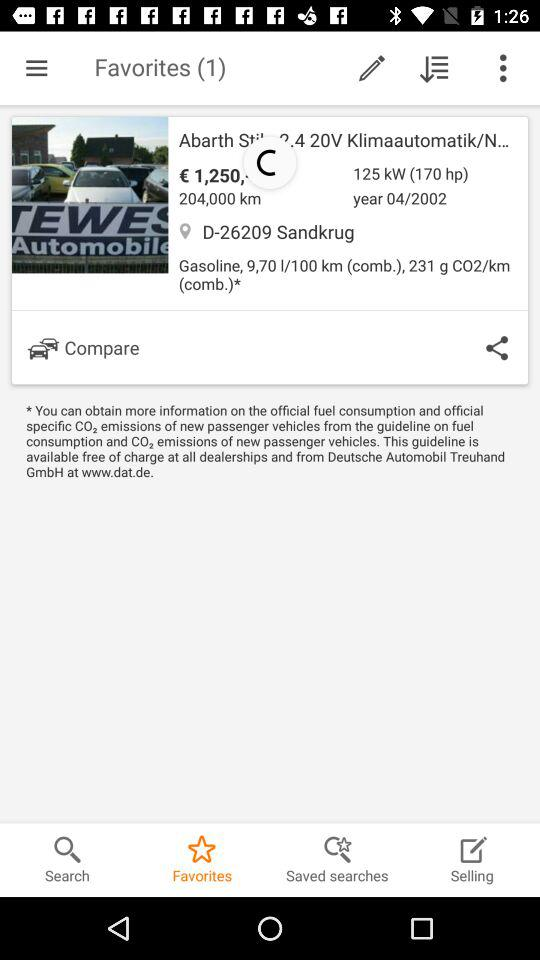How many kilometers are on this car?
Answer the question using a single word or phrase. 204,000 km 